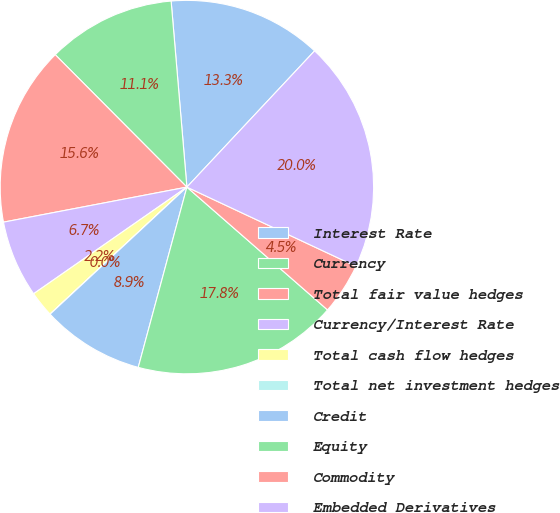Convert chart. <chart><loc_0><loc_0><loc_500><loc_500><pie_chart><fcel>Interest Rate<fcel>Currency<fcel>Total fair value hedges<fcel>Currency/Interest Rate<fcel>Total cash flow hedges<fcel>Total net investment hedges<fcel>Credit<fcel>Equity<fcel>Commodity<fcel>Embedded Derivatives<nl><fcel>13.33%<fcel>11.11%<fcel>15.55%<fcel>6.67%<fcel>2.23%<fcel>0.01%<fcel>8.89%<fcel>17.77%<fcel>4.45%<fcel>19.99%<nl></chart> 